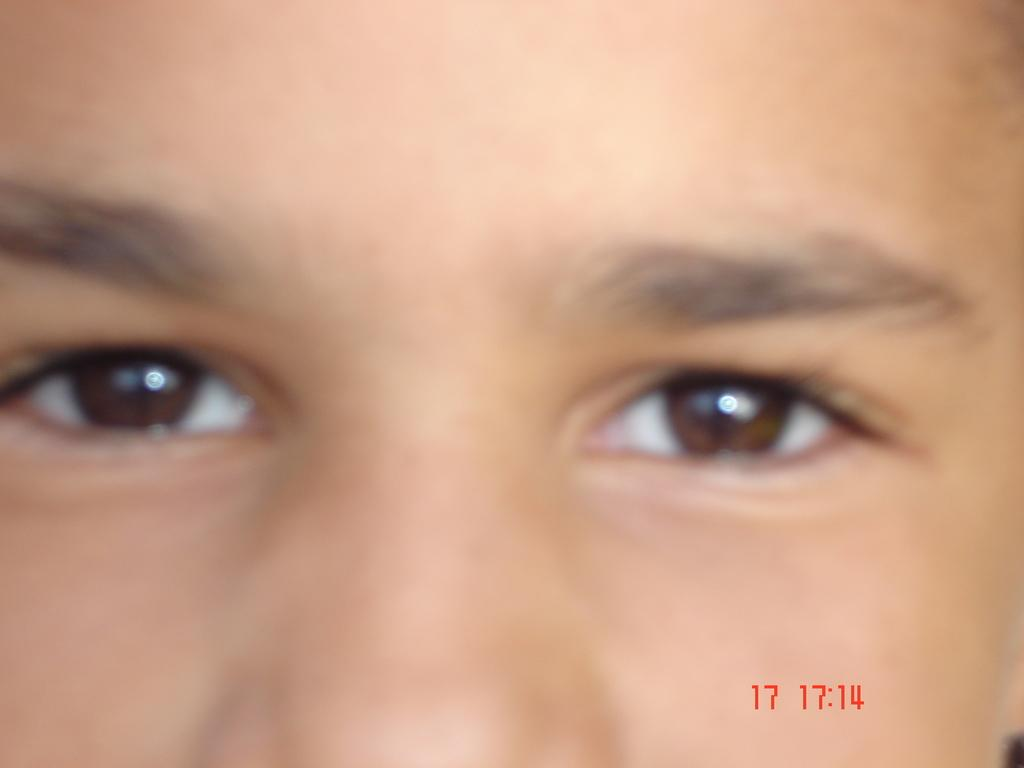What facial features are visible in the image? There is a person's eyes and nose in the image. Where are the numbers located in the image? The numbers are in red color at the right bottom of the image. What type of box is being shaded by the apple in the image? There is no box or apple present in the image. 